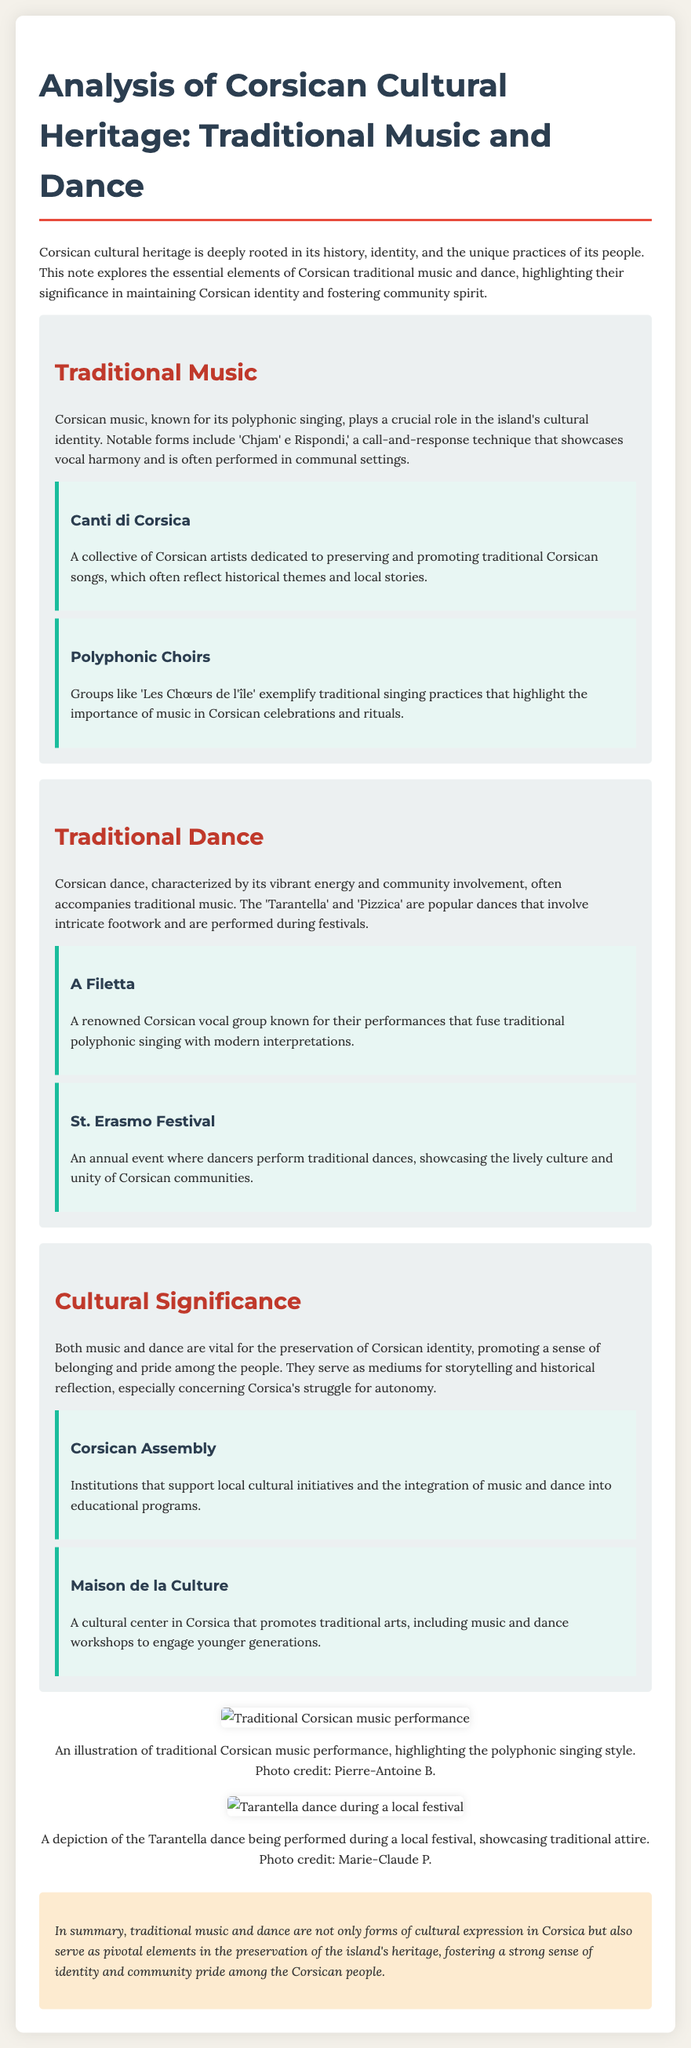What is the title of the document? The title of the document is clearly stated at the beginning of the note, "Analysis of Corsican Cultural Heritage: Traditional Music and Dance."
Answer: Analysis of Corsican Cultural Heritage: Traditional Music and Dance What technique is used in Corsican polyphonic singing? The technique highlighted in the document as being used in Corsican music is 'Chjam' e Rispondi,' a call-and-response method.
Answer: Chjam' e Rispondi Name one collective that promotes traditional Corsican songs. The document provides a specific name of a collective that promotes traditional songs: "Canti di Corsica."
Answer: Canti di Corsica What is the St. Erasmo Festival known for? The document states that the St. Erasmo Festival is an annual event where traditional dances are performed, showcasing Corsican culture.
Answer: Traditional dances Which dance is mentioned alongside the vibrant energy of Corsican dance? The document lists the 'Tarantella' as one of the popular dances characterized by vibrant energy and intricate footwork.
Answer: Tarantella Who supports local cultural initiatives in Corsica? The document mentions the "Corsican Assembly" as an organization that supports local cultural initiatives.
Answer: Corsican Assembly What is highlighted as a cultural center that promotes traditional arts? The document specifically identifies "Maison de la Culture" as a cultural center in Corsica promoting traditional arts.
Answer: Maison de la Culture What is the role of music and dance in Corsican identity? The document discusses that both music and dance are vital for the preservation of Corsican identity and promote pride among the people.
Answer: Preservation of Corsican identity Who is credited with the photo of the traditional Corsican music performance? The document attributes the photo of the music performance to Pierre-Antoine B.
Answer: Pierre-Antoine B 